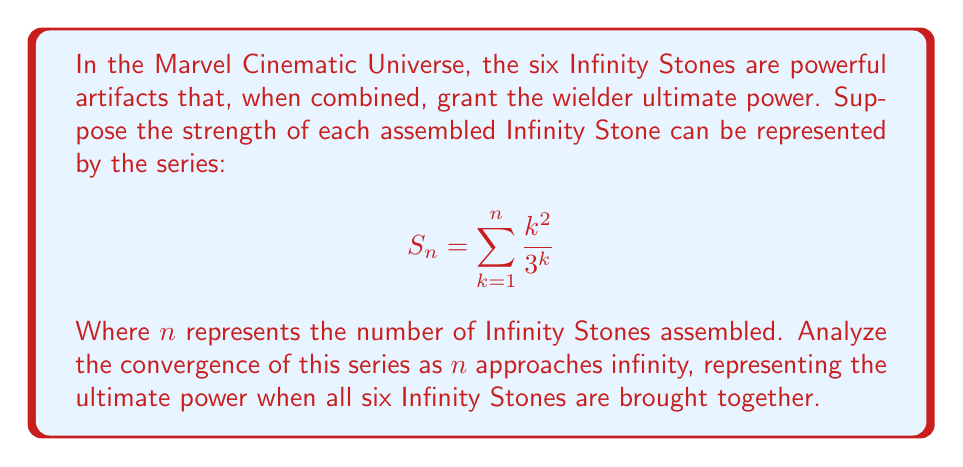What is the answer to this math problem? To analyze the convergence of this series, we'll use the ratio test:

1) First, we'll find the general term of the series:
   $a_k = \frac{k^2}{3^k}$

2) Now, we'll apply the ratio test:
   $$\lim_{k \to \infty} \left|\frac{a_{k+1}}{a_k}\right| = \lim_{k \to \infty} \left|\frac{(k+1)^2}{3^{k+1}} \cdot \frac{3^k}{k^2}\right|$$

3) Simplify:
   $$\lim_{k \to \infty} \left|\frac{(k+1)^2}{3k^2}\right| = \lim_{k \to \infty} \frac{1}{3} \cdot \left(\frac{k+1}{k}\right)^2$$

4) Evaluate the limit:
   $$\lim_{k \to \infty} \frac{1}{3} \cdot \left(1 + \frac{1}{k}\right)^2 = \frac{1}{3} < 1$$

5) Since the limit is less than 1, by the ratio test, the series converges.

6) To find the sum of the series, we can use the formula for the sum of a geometric series with an additional factor:
   $$S = \sum_{k=1}^{\infty} k^2x^k = \frac{x(1+x)}{(1-x)^3}, \text{ where } |x| < 1$$

   In our case, $x = \frac{1}{3}$

7) Substituting $x = \frac{1}{3}$ into the formula:
   $$S_{\infty} = \frac{\frac{1}{3}(1+\frac{1}{3})}{(1-\frac{1}{3})^3} = \frac{\frac{4}{9}}{\frac{8}{27}} = \frac{4}{9} \cdot \frac{27}{8} = \frac{3}{2} = 1.5$$

Therefore, the series converges to $\frac{3}{2}$ or 1.5.
Answer: The series converges to $\frac{3}{2}$ or 1.5. 